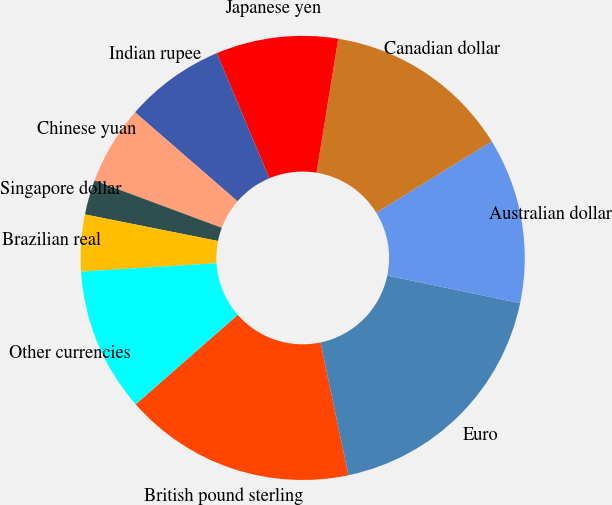Convert chart to OTSL. <chart><loc_0><loc_0><loc_500><loc_500><pie_chart><fcel>British pound sterling<fcel>Euro<fcel>Australian dollar<fcel>Canadian dollar<fcel>Japanese yen<fcel>Indian rupee<fcel>Chinese yuan<fcel>Singapore dollar<fcel>Brazilian real<fcel>Other currencies<nl><fcel>16.85%<fcel>18.43%<fcel>12.06%<fcel>13.65%<fcel>8.88%<fcel>7.3%<fcel>5.71%<fcel>2.53%<fcel>4.12%<fcel>10.47%<nl></chart> 